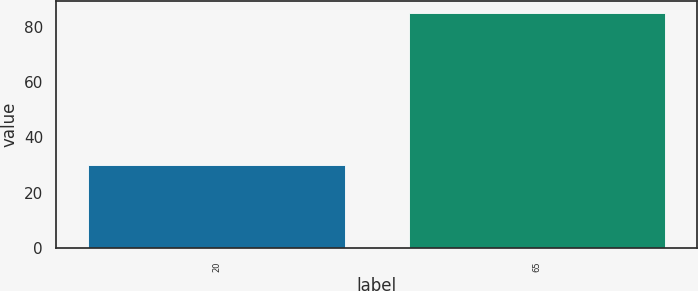Convert chart to OTSL. <chart><loc_0><loc_0><loc_500><loc_500><bar_chart><fcel>20<fcel>65<nl><fcel>30<fcel>85<nl></chart> 